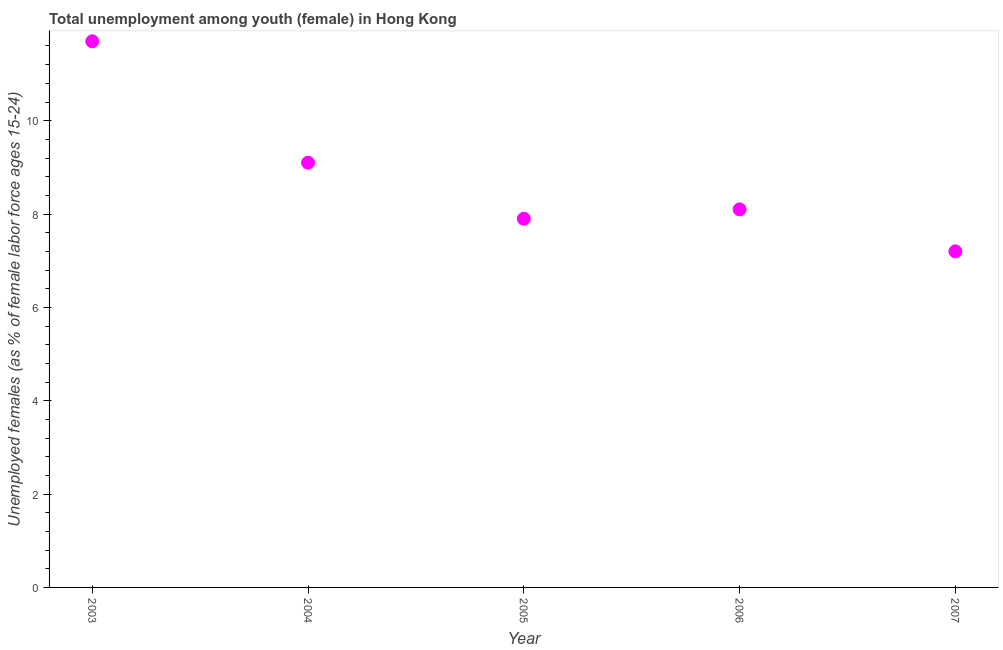What is the unemployed female youth population in 2003?
Offer a terse response. 11.7. Across all years, what is the maximum unemployed female youth population?
Your answer should be very brief. 11.7. Across all years, what is the minimum unemployed female youth population?
Make the answer very short. 7.2. In which year was the unemployed female youth population maximum?
Offer a very short reply. 2003. In which year was the unemployed female youth population minimum?
Your answer should be very brief. 2007. What is the sum of the unemployed female youth population?
Your answer should be compact. 44. What is the difference between the unemployed female youth population in 2003 and 2004?
Your answer should be compact. 2.6. What is the average unemployed female youth population per year?
Offer a very short reply. 8.8. What is the median unemployed female youth population?
Your response must be concise. 8.1. In how many years, is the unemployed female youth population greater than 7.6 %?
Give a very brief answer. 4. Do a majority of the years between 2007 and 2003 (inclusive) have unemployed female youth population greater than 11.2 %?
Provide a short and direct response. Yes. What is the ratio of the unemployed female youth population in 2004 to that in 2006?
Your answer should be compact. 1.12. Is the unemployed female youth population in 2006 less than that in 2007?
Keep it short and to the point. No. What is the difference between the highest and the second highest unemployed female youth population?
Your answer should be compact. 2.6. Is the sum of the unemployed female youth population in 2003 and 2006 greater than the maximum unemployed female youth population across all years?
Offer a terse response. Yes. What is the difference between the highest and the lowest unemployed female youth population?
Ensure brevity in your answer.  4.5. In how many years, is the unemployed female youth population greater than the average unemployed female youth population taken over all years?
Give a very brief answer. 2. Does the unemployed female youth population monotonically increase over the years?
Make the answer very short. No. How many dotlines are there?
Offer a terse response. 1. What is the difference between two consecutive major ticks on the Y-axis?
Ensure brevity in your answer.  2. What is the title of the graph?
Your response must be concise. Total unemployment among youth (female) in Hong Kong. What is the label or title of the X-axis?
Provide a short and direct response. Year. What is the label or title of the Y-axis?
Your answer should be compact. Unemployed females (as % of female labor force ages 15-24). What is the Unemployed females (as % of female labor force ages 15-24) in 2003?
Give a very brief answer. 11.7. What is the Unemployed females (as % of female labor force ages 15-24) in 2004?
Your answer should be compact. 9.1. What is the Unemployed females (as % of female labor force ages 15-24) in 2005?
Provide a succinct answer. 7.9. What is the Unemployed females (as % of female labor force ages 15-24) in 2006?
Your answer should be compact. 8.1. What is the Unemployed females (as % of female labor force ages 15-24) in 2007?
Offer a terse response. 7.2. What is the difference between the Unemployed females (as % of female labor force ages 15-24) in 2003 and 2004?
Your answer should be compact. 2.6. What is the difference between the Unemployed females (as % of female labor force ages 15-24) in 2003 and 2007?
Keep it short and to the point. 4.5. What is the difference between the Unemployed females (as % of female labor force ages 15-24) in 2004 and 2005?
Provide a succinct answer. 1.2. What is the difference between the Unemployed females (as % of female labor force ages 15-24) in 2004 and 2006?
Make the answer very short. 1. What is the difference between the Unemployed females (as % of female labor force ages 15-24) in 2004 and 2007?
Your answer should be very brief. 1.9. What is the difference between the Unemployed females (as % of female labor force ages 15-24) in 2006 and 2007?
Provide a short and direct response. 0.9. What is the ratio of the Unemployed females (as % of female labor force ages 15-24) in 2003 to that in 2004?
Keep it short and to the point. 1.29. What is the ratio of the Unemployed females (as % of female labor force ages 15-24) in 2003 to that in 2005?
Your response must be concise. 1.48. What is the ratio of the Unemployed females (as % of female labor force ages 15-24) in 2003 to that in 2006?
Provide a succinct answer. 1.44. What is the ratio of the Unemployed females (as % of female labor force ages 15-24) in 2003 to that in 2007?
Your answer should be compact. 1.62. What is the ratio of the Unemployed females (as % of female labor force ages 15-24) in 2004 to that in 2005?
Provide a succinct answer. 1.15. What is the ratio of the Unemployed females (as % of female labor force ages 15-24) in 2004 to that in 2006?
Ensure brevity in your answer.  1.12. What is the ratio of the Unemployed females (as % of female labor force ages 15-24) in 2004 to that in 2007?
Provide a succinct answer. 1.26. What is the ratio of the Unemployed females (as % of female labor force ages 15-24) in 2005 to that in 2007?
Your response must be concise. 1.1. What is the ratio of the Unemployed females (as % of female labor force ages 15-24) in 2006 to that in 2007?
Keep it short and to the point. 1.12. 